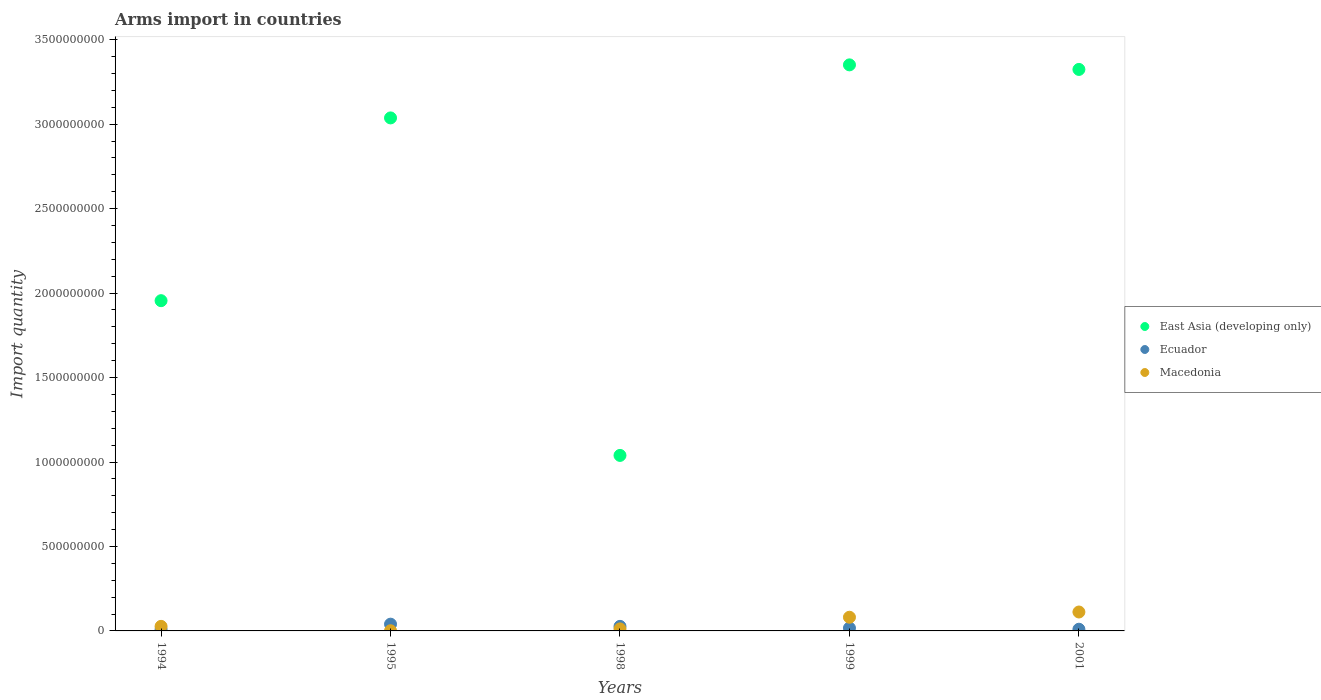How many different coloured dotlines are there?
Provide a short and direct response. 3. What is the total arms import in Macedonia in 2001?
Provide a short and direct response. 1.12e+08. Across all years, what is the maximum total arms import in East Asia (developing only)?
Your response must be concise. 3.35e+09. Across all years, what is the minimum total arms import in Macedonia?
Offer a terse response. 1.00e+06. What is the total total arms import in East Asia (developing only) in the graph?
Provide a succinct answer. 1.27e+1. What is the difference between the total arms import in Macedonia in 1998 and that in 1999?
Offer a very short reply. -6.90e+07. What is the difference between the total arms import in Ecuador in 1999 and the total arms import in Macedonia in 2001?
Your response must be concise. -9.50e+07. What is the average total arms import in Ecuador per year?
Provide a short and direct response. 2.06e+07. In the year 2001, what is the difference between the total arms import in Ecuador and total arms import in East Asia (developing only)?
Your answer should be very brief. -3.31e+09. What is the ratio of the total arms import in Ecuador in 1994 to that in 1999?
Make the answer very short. 0.53. Is the difference between the total arms import in Ecuador in 1998 and 2001 greater than the difference between the total arms import in East Asia (developing only) in 1998 and 2001?
Offer a very short reply. Yes. What is the difference between the highest and the second highest total arms import in East Asia (developing only)?
Offer a very short reply. 2.70e+07. What is the difference between the highest and the lowest total arms import in Ecuador?
Provide a short and direct response. 3.10e+07. In how many years, is the total arms import in Ecuador greater than the average total arms import in Ecuador taken over all years?
Your answer should be very brief. 2. Does the total arms import in Ecuador monotonically increase over the years?
Offer a terse response. No. How many years are there in the graph?
Offer a very short reply. 5. What is the difference between two consecutive major ticks on the Y-axis?
Make the answer very short. 5.00e+08. Does the graph contain any zero values?
Provide a short and direct response. No. Does the graph contain grids?
Your answer should be compact. No. Where does the legend appear in the graph?
Ensure brevity in your answer.  Center right. What is the title of the graph?
Your response must be concise. Arms import in countries. What is the label or title of the Y-axis?
Ensure brevity in your answer.  Import quantity. What is the Import quantity of East Asia (developing only) in 1994?
Give a very brief answer. 1.96e+09. What is the Import quantity in Ecuador in 1994?
Your response must be concise. 9.00e+06. What is the Import quantity of Macedonia in 1994?
Provide a short and direct response. 2.70e+07. What is the Import quantity in East Asia (developing only) in 1995?
Make the answer very short. 3.04e+09. What is the Import quantity in Ecuador in 1995?
Provide a short and direct response. 4.00e+07. What is the Import quantity in Macedonia in 1995?
Your answer should be compact. 1.00e+06. What is the Import quantity in East Asia (developing only) in 1998?
Give a very brief answer. 1.04e+09. What is the Import quantity of Ecuador in 1998?
Provide a succinct answer. 2.70e+07. What is the Import quantity of East Asia (developing only) in 1999?
Your response must be concise. 3.35e+09. What is the Import quantity of Ecuador in 1999?
Offer a very short reply. 1.70e+07. What is the Import quantity in Macedonia in 1999?
Your answer should be very brief. 8.10e+07. What is the Import quantity in East Asia (developing only) in 2001?
Ensure brevity in your answer.  3.32e+09. What is the Import quantity of Macedonia in 2001?
Offer a terse response. 1.12e+08. Across all years, what is the maximum Import quantity of East Asia (developing only)?
Your response must be concise. 3.35e+09. Across all years, what is the maximum Import quantity of Ecuador?
Offer a very short reply. 4.00e+07. Across all years, what is the maximum Import quantity of Macedonia?
Give a very brief answer. 1.12e+08. Across all years, what is the minimum Import quantity in East Asia (developing only)?
Ensure brevity in your answer.  1.04e+09. Across all years, what is the minimum Import quantity in Ecuador?
Make the answer very short. 9.00e+06. Across all years, what is the minimum Import quantity in Macedonia?
Provide a short and direct response. 1.00e+06. What is the total Import quantity in East Asia (developing only) in the graph?
Your answer should be very brief. 1.27e+1. What is the total Import quantity of Ecuador in the graph?
Offer a terse response. 1.03e+08. What is the total Import quantity of Macedonia in the graph?
Your response must be concise. 2.33e+08. What is the difference between the Import quantity of East Asia (developing only) in 1994 and that in 1995?
Offer a terse response. -1.08e+09. What is the difference between the Import quantity of Ecuador in 1994 and that in 1995?
Ensure brevity in your answer.  -3.10e+07. What is the difference between the Import quantity in Macedonia in 1994 and that in 1995?
Your response must be concise. 2.60e+07. What is the difference between the Import quantity in East Asia (developing only) in 1994 and that in 1998?
Keep it short and to the point. 9.16e+08. What is the difference between the Import quantity in Ecuador in 1994 and that in 1998?
Ensure brevity in your answer.  -1.80e+07. What is the difference between the Import quantity of Macedonia in 1994 and that in 1998?
Provide a short and direct response. 1.50e+07. What is the difference between the Import quantity of East Asia (developing only) in 1994 and that in 1999?
Ensure brevity in your answer.  -1.40e+09. What is the difference between the Import quantity of Ecuador in 1994 and that in 1999?
Ensure brevity in your answer.  -8.00e+06. What is the difference between the Import quantity of Macedonia in 1994 and that in 1999?
Your answer should be compact. -5.40e+07. What is the difference between the Import quantity of East Asia (developing only) in 1994 and that in 2001?
Offer a very short reply. -1.37e+09. What is the difference between the Import quantity of Macedonia in 1994 and that in 2001?
Your response must be concise. -8.50e+07. What is the difference between the Import quantity in East Asia (developing only) in 1995 and that in 1998?
Your answer should be very brief. 2.00e+09. What is the difference between the Import quantity in Ecuador in 1995 and that in 1998?
Ensure brevity in your answer.  1.30e+07. What is the difference between the Import quantity in Macedonia in 1995 and that in 1998?
Offer a very short reply. -1.10e+07. What is the difference between the Import quantity in East Asia (developing only) in 1995 and that in 1999?
Your response must be concise. -3.14e+08. What is the difference between the Import quantity of Ecuador in 1995 and that in 1999?
Your answer should be very brief. 2.30e+07. What is the difference between the Import quantity in Macedonia in 1995 and that in 1999?
Offer a very short reply. -8.00e+07. What is the difference between the Import quantity of East Asia (developing only) in 1995 and that in 2001?
Your response must be concise. -2.87e+08. What is the difference between the Import quantity in Ecuador in 1995 and that in 2001?
Offer a very short reply. 3.00e+07. What is the difference between the Import quantity of Macedonia in 1995 and that in 2001?
Provide a short and direct response. -1.11e+08. What is the difference between the Import quantity in East Asia (developing only) in 1998 and that in 1999?
Offer a terse response. -2.31e+09. What is the difference between the Import quantity of Ecuador in 1998 and that in 1999?
Provide a short and direct response. 1.00e+07. What is the difference between the Import quantity of Macedonia in 1998 and that in 1999?
Your response must be concise. -6.90e+07. What is the difference between the Import quantity in East Asia (developing only) in 1998 and that in 2001?
Make the answer very short. -2.28e+09. What is the difference between the Import quantity in Ecuador in 1998 and that in 2001?
Offer a very short reply. 1.70e+07. What is the difference between the Import quantity in Macedonia in 1998 and that in 2001?
Give a very brief answer. -1.00e+08. What is the difference between the Import quantity of East Asia (developing only) in 1999 and that in 2001?
Your response must be concise. 2.70e+07. What is the difference between the Import quantity of Macedonia in 1999 and that in 2001?
Your response must be concise. -3.10e+07. What is the difference between the Import quantity in East Asia (developing only) in 1994 and the Import quantity in Ecuador in 1995?
Offer a terse response. 1.92e+09. What is the difference between the Import quantity of East Asia (developing only) in 1994 and the Import quantity of Macedonia in 1995?
Provide a short and direct response. 1.95e+09. What is the difference between the Import quantity of East Asia (developing only) in 1994 and the Import quantity of Ecuador in 1998?
Your response must be concise. 1.93e+09. What is the difference between the Import quantity of East Asia (developing only) in 1994 and the Import quantity of Macedonia in 1998?
Offer a very short reply. 1.94e+09. What is the difference between the Import quantity in Ecuador in 1994 and the Import quantity in Macedonia in 1998?
Offer a very short reply. -3.00e+06. What is the difference between the Import quantity in East Asia (developing only) in 1994 and the Import quantity in Ecuador in 1999?
Give a very brief answer. 1.94e+09. What is the difference between the Import quantity in East Asia (developing only) in 1994 and the Import quantity in Macedonia in 1999?
Provide a succinct answer. 1.87e+09. What is the difference between the Import quantity in Ecuador in 1994 and the Import quantity in Macedonia in 1999?
Your response must be concise. -7.20e+07. What is the difference between the Import quantity in East Asia (developing only) in 1994 and the Import quantity in Ecuador in 2001?
Your answer should be very brief. 1.94e+09. What is the difference between the Import quantity in East Asia (developing only) in 1994 and the Import quantity in Macedonia in 2001?
Provide a short and direct response. 1.84e+09. What is the difference between the Import quantity of Ecuador in 1994 and the Import quantity of Macedonia in 2001?
Your answer should be compact. -1.03e+08. What is the difference between the Import quantity in East Asia (developing only) in 1995 and the Import quantity in Ecuador in 1998?
Give a very brief answer. 3.01e+09. What is the difference between the Import quantity in East Asia (developing only) in 1995 and the Import quantity in Macedonia in 1998?
Keep it short and to the point. 3.02e+09. What is the difference between the Import quantity in Ecuador in 1995 and the Import quantity in Macedonia in 1998?
Provide a succinct answer. 2.80e+07. What is the difference between the Import quantity in East Asia (developing only) in 1995 and the Import quantity in Ecuador in 1999?
Provide a short and direct response. 3.02e+09. What is the difference between the Import quantity of East Asia (developing only) in 1995 and the Import quantity of Macedonia in 1999?
Provide a short and direct response. 2.96e+09. What is the difference between the Import quantity of Ecuador in 1995 and the Import quantity of Macedonia in 1999?
Your answer should be compact. -4.10e+07. What is the difference between the Import quantity of East Asia (developing only) in 1995 and the Import quantity of Ecuador in 2001?
Your response must be concise. 3.03e+09. What is the difference between the Import quantity in East Asia (developing only) in 1995 and the Import quantity in Macedonia in 2001?
Your response must be concise. 2.92e+09. What is the difference between the Import quantity of Ecuador in 1995 and the Import quantity of Macedonia in 2001?
Make the answer very short. -7.20e+07. What is the difference between the Import quantity of East Asia (developing only) in 1998 and the Import quantity of Ecuador in 1999?
Offer a terse response. 1.02e+09. What is the difference between the Import quantity in East Asia (developing only) in 1998 and the Import quantity in Macedonia in 1999?
Your response must be concise. 9.58e+08. What is the difference between the Import quantity of Ecuador in 1998 and the Import quantity of Macedonia in 1999?
Ensure brevity in your answer.  -5.40e+07. What is the difference between the Import quantity of East Asia (developing only) in 1998 and the Import quantity of Ecuador in 2001?
Offer a terse response. 1.03e+09. What is the difference between the Import quantity of East Asia (developing only) in 1998 and the Import quantity of Macedonia in 2001?
Your answer should be very brief. 9.27e+08. What is the difference between the Import quantity in Ecuador in 1998 and the Import quantity in Macedonia in 2001?
Keep it short and to the point. -8.50e+07. What is the difference between the Import quantity of East Asia (developing only) in 1999 and the Import quantity of Ecuador in 2001?
Ensure brevity in your answer.  3.34e+09. What is the difference between the Import quantity in East Asia (developing only) in 1999 and the Import quantity in Macedonia in 2001?
Offer a terse response. 3.24e+09. What is the difference between the Import quantity in Ecuador in 1999 and the Import quantity in Macedonia in 2001?
Keep it short and to the point. -9.50e+07. What is the average Import quantity in East Asia (developing only) per year?
Your answer should be compact. 2.54e+09. What is the average Import quantity of Ecuador per year?
Provide a short and direct response. 2.06e+07. What is the average Import quantity of Macedonia per year?
Offer a terse response. 4.66e+07. In the year 1994, what is the difference between the Import quantity of East Asia (developing only) and Import quantity of Ecuador?
Offer a very short reply. 1.95e+09. In the year 1994, what is the difference between the Import quantity in East Asia (developing only) and Import quantity in Macedonia?
Offer a terse response. 1.93e+09. In the year 1994, what is the difference between the Import quantity of Ecuador and Import quantity of Macedonia?
Your answer should be compact. -1.80e+07. In the year 1995, what is the difference between the Import quantity of East Asia (developing only) and Import quantity of Ecuador?
Give a very brief answer. 3.00e+09. In the year 1995, what is the difference between the Import quantity in East Asia (developing only) and Import quantity in Macedonia?
Your response must be concise. 3.04e+09. In the year 1995, what is the difference between the Import quantity in Ecuador and Import quantity in Macedonia?
Provide a succinct answer. 3.90e+07. In the year 1998, what is the difference between the Import quantity in East Asia (developing only) and Import quantity in Ecuador?
Your answer should be very brief. 1.01e+09. In the year 1998, what is the difference between the Import quantity in East Asia (developing only) and Import quantity in Macedonia?
Make the answer very short. 1.03e+09. In the year 1998, what is the difference between the Import quantity in Ecuador and Import quantity in Macedonia?
Your answer should be very brief. 1.50e+07. In the year 1999, what is the difference between the Import quantity of East Asia (developing only) and Import quantity of Ecuador?
Make the answer very short. 3.33e+09. In the year 1999, what is the difference between the Import quantity of East Asia (developing only) and Import quantity of Macedonia?
Your response must be concise. 3.27e+09. In the year 1999, what is the difference between the Import quantity in Ecuador and Import quantity in Macedonia?
Your response must be concise. -6.40e+07. In the year 2001, what is the difference between the Import quantity in East Asia (developing only) and Import quantity in Ecuador?
Provide a succinct answer. 3.31e+09. In the year 2001, what is the difference between the Import quantity of East Asia (developing only) and Import quantity of Macedonia?
Your answer should be very brief. 3.21e+09. In the year 2001, what is the difference between the Import quantity of Ecuador and Import quantity of Macedonia?
Your answer should be compact. -1.02e+08. What is the ratio of the Import quantity of East Asia (developing only) in 1994 to that in 1995?
Your answer should be compact. 0.64. What is the ratio of the Import quantity in Ecuador in 1994 to that in 1995?
Make the answer very short. 0.23. What is the ratio of the Import quantity of Macedonia in 1994 to that in 1995?
Ensure brevity in your answer.  27. What is the ratio of the Import quantity of East Asia (developing only) in 1994 to that in 1998?
Ensure brevity in your answer.  1.88. What is the ratio of the Import quantity in Ecuador in 1994 to that in 1998?
Provide a succinct answer. 0.33. What is the ratio of the Import quantity in Macedonia in 1994 to that in 1998?
Offer a terse response. 2.25. What is the ratio of the Import quantity in East Asia (developing only) in 1994 to that in 1999?
Offer a terse response. 0.58. What is the ratio of the Import quantity of Ecuador in 1994 to that in 1999?
Make the answer very short. 0.53. What is the ratio of the Import quantity in Macedonia in 1994 to that in 1999?
Provide a short and direct response. 0.33. What is the ratio of the Import quantity of East Asia (developing only) in 1994 to that in 2001?
Make the answer very short. 0.59. What is the ratio of the Import quantity of Ecuador in 1994 to that in 2001?
Make the answer very short. 0.9. What is the ratio of the Import quantity of Macedonia in 1994 to that in 2001?
Provide a short and direct response. 0.24. What is the ratio of the Import quantity in East Asia (developing only) in 1995 to that in 1998?
Make the answer very short. 2.92. What is the ratio of the Import quantity of Ecuador in 1995 to that in 1998?
Offer a terse response. 1.48. What is the ratio of the Import quantity of Macedonia in 1995 to that in 1998?
Provide a succinct answer. 0.08. What is the ratio of the Import quantity of East Asia (developing only) in 1995 to that in 1999?
Keep it short and to the point. 0.91. What is the ratio of the Import quantity in Ecuador in 1995 to that in 1999?
Keep it short and to the point. 2.35. What is the ratio of the Import quantity of Macedonia in 1995 to that in 1999?
Give a very brief answer. 0.01. What is the ratio of the Import quantity in East Asia (developing only) in 1995 to that in 2001?
Keep it short and to the point. 0.91. What is the ratio of the Import quantity in Macedonia in 1995 to that in 2001?
Give a very brief answer. 0.01. What is the ratio of the Import quantity in East Asia (developing only) in 1998 to that in 1999?
Keep it short and to the point. 0.31. What is the ratio of the Import quantity of Ecuador in 1998 to that in 1999?
Keep it short and to the point. 1.59. What is the ratio of the Import quantity of Macedonia in 1998 to that in 1999?
Keep it short and to the point. 0.15. What is the ratio of the Import quantity of East Asia (developing only) in 1998 to that in 2001?
Give a very brief answer. 0.31. What is the ratio of the Import quantity of Ecuador in 1998 to that in 2001?
Give a very brief answer. 2.7. What is the ratio of the Import quantity of Macedonia in 1998 to that in 2001?
Ensure brevity in your answer.  0.11. What is the ratio of the Import quantity of East Asia (developing only) in 1999 to that in 2001?
Your response must be concise. 1.01. What is the ratio of the Import quantity in Ecuador in 1999 to that in 2001?
Ensure brevity in your answer.  1.7. What is the ratio of the Import quantity of Macedonia in 1999 to that in 2001?
Give a very brief answer. 0.72. What is the difference between the highest and the second highest Import quantity of East Asia (developing only)?
Make the answer very short. 2.70e+07. What is the difference between the highest and the second highest Import quantity of Ecuador?
Provide a short and direct response. 1.30e+07. What is the difference between the highest and the second highest Import quantity of Macedonia?
Give a very brief answer. 3.10e+07. What is the difference between the highest and the lowest Import quantity in East Asia (developing only)?
Offer a very short reply. 2.31e+09. What is the difference between the highest and the lowest Import quantity in Ecuador?
Make the answer very short. 3.10e+07. What is the difference between the highest and the lowest Import quantity of Macedonia?
Give a very brief answer. 1.11e+08. 